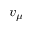<formula> <loc_0><loc_0><loc_500><loc_500>v _ { \mu }</formula> 